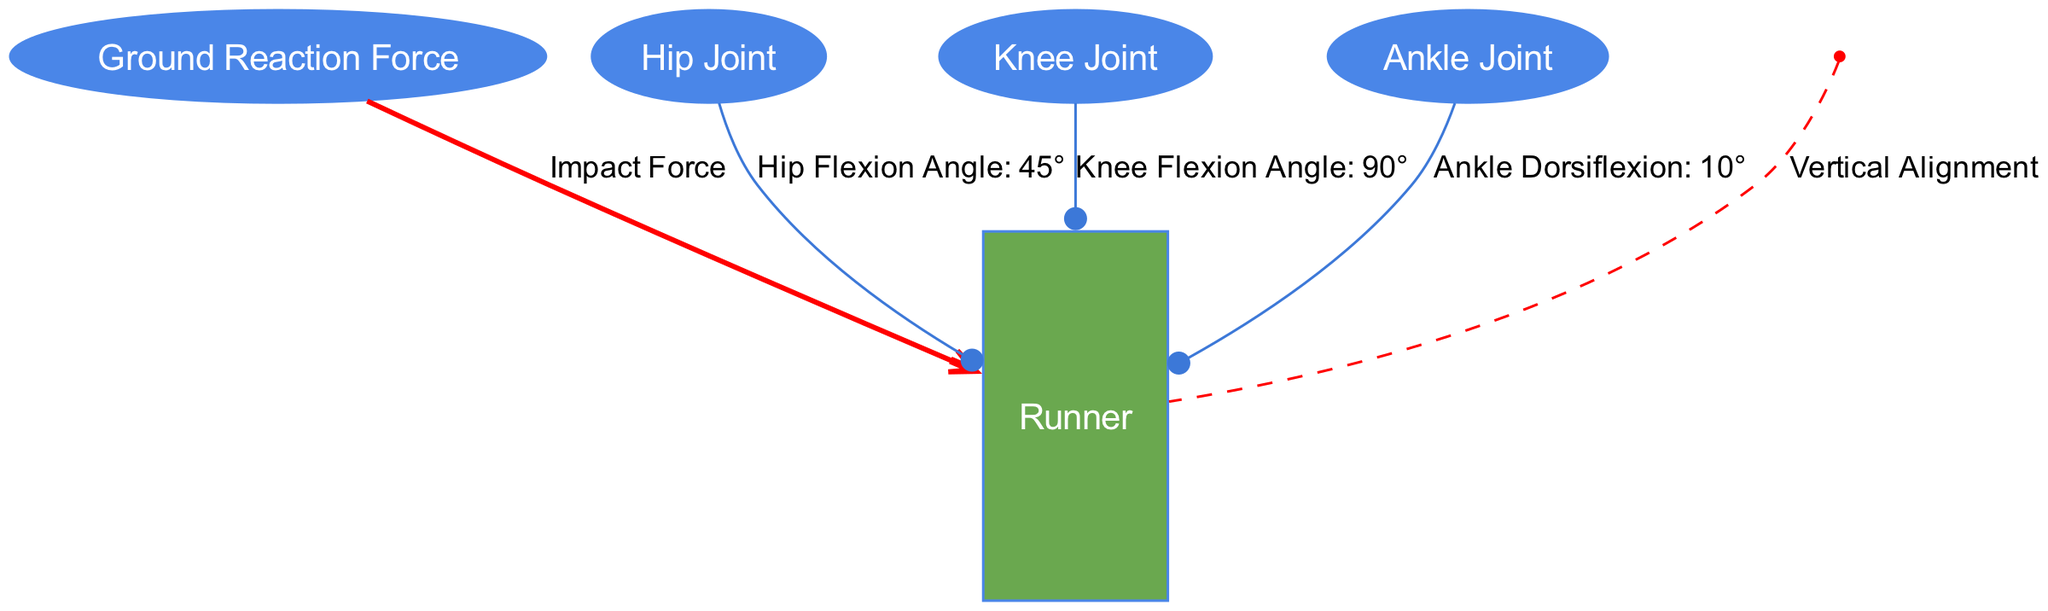What is the impact force acting on the runner? The diagram shows an edge coming from the "Ground Reaction Force" node to the "Runner" node labeled "Impact Force". Therefore, the impact force acting on the runner is clearly indicated in the diagram.
Answer: Impact Force What is the hip flexion angle associated with the runner? The edge connecting the "Hip Joint" node to the "Runner" node is labeled "Hip Flexion Angle: 45°". This label directly provides the measurement for the hip flexion angle.
Answer: 45° How many joints are depicted in the diagram? The diagram features three joints: Hip Joint, Knee Joint, and Ankle Joint. By counting the nodes labeled with "Joint", we find there are three distinct joints.
Answer: 3 What angle does the knee joint flex to? The edge from the "Knee Joint" node to the "Runner" node indicates "Knee Flexion Angle: 90°". This provides the specific flexion angle at the knee joint.
Answer: 90° What is the degree of ankle dorsiflexion shown? The connection from the "Ankle Joint" node to the "Runner" node specifies "Ankle Dorsiflexion: 10°". This label gives the exact measurement for ankle dorsiflexion.
Answer: 10° In what direction is the center of mass aligned with the runner? The edge between the "Center of Mass" node and the "Runner" node shows "Vertical Alignment". This describes how the center of mass is oriented concerning the runner's body.
Answer: Vertical Alignment What type of force do the ground reaction forces apply to the runner? The ground reaction force applies an "Impact Force" to the runner, as indicated by the direct labeling of the edge connecting these two nodes.
Answer: Impact Force How is the relationship between the center of mass and the runner illustrated? The association is indicated through a dashed edge leading from the "Center of Mass" node to the "Runner" node, labeled with "Vertical Alignment". This signifies how the center of mass relates to the runner’s posture.
Answer: Dashed edge with "Vertical Alignment" 